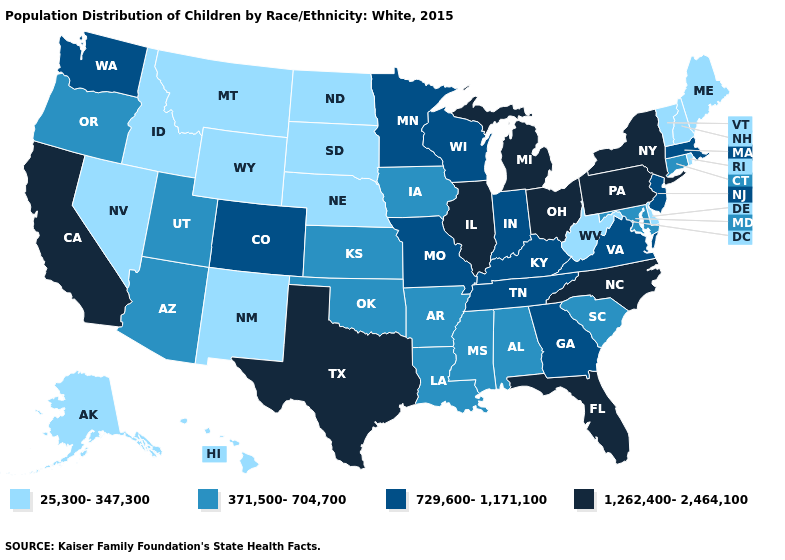Name the states that have a value in the range 25,300-347,300?
Quick response, please. Alaska, Delaware, Hawaii, Idaho, Maine, Montana, Nebraska, Nevada, New Hampshire, New Mexico, North Dakota, Rhode Island, South Dakota, Vermont, West Virginia, Wyoming. Which states have the highest value in the USA?
Give a very brief answer. California, Florida, Illinois, Michigan, New York, North Carolina, Ohio, Pennsylvania, Texas. What is the value of Indiana?
Keep it brief. 729,600-1,171,100. What is the value of Iowa?
Give a very brief answer. 371,500-704,700. What is the highest value in states that border Mississippi?
Short answer required. 729,600-1,171,100. Does California have the same value as North Carolina?
Keep it brief. Yes. What is the lowest value in the USA?
Keep it brief. 25,300-347,300. Does the map have missing data?
Quick response, please. No. What is the lowest value in states that border Kansas?
Concise answer only. 25,300-347,300. Name the states that have a value in the range 25,300-347,300?
Short answer required. Alaska, Delaware, Hawaii, Idaho, Maine, Montana, Nebraska, Nevada, New Hampshire, New Mexico, North Dakota, Rhode Island, South Dakota, Vermont, West Virginia, Wyoming. What is the lowest value in the USA?
Write a very short answer. 25,300-347,300. Name the states that have a value in the range 1,262,400-2,464,100?
Concise answer only. California, Florida, Illinois, Michigan, New York, North Carolina, Ohio, Pennsylvania, Texas. What is the value of Delaware?
Quick response, please. 25,300-347,300. Name the states that have a value in the range 729,600-1,171,100?
Be succinct. Colorado, Georgia, Indiana, Kentucky, Massachusetts, Minnesota, Missouri, New Jersey, Tennessee, Virginia, Washington, Wisconsin. Name the states that have a value in the range 25,300-347,300?
Concise answer only. Alaska, Delaware, Hawaii, Idaho, Maine, Montana, Nebraska, Nevada, New Hampshire, New Mexico, North Dakota, Rhode Island, South Dakota, Vermont, West Virginia, Wyoming. 